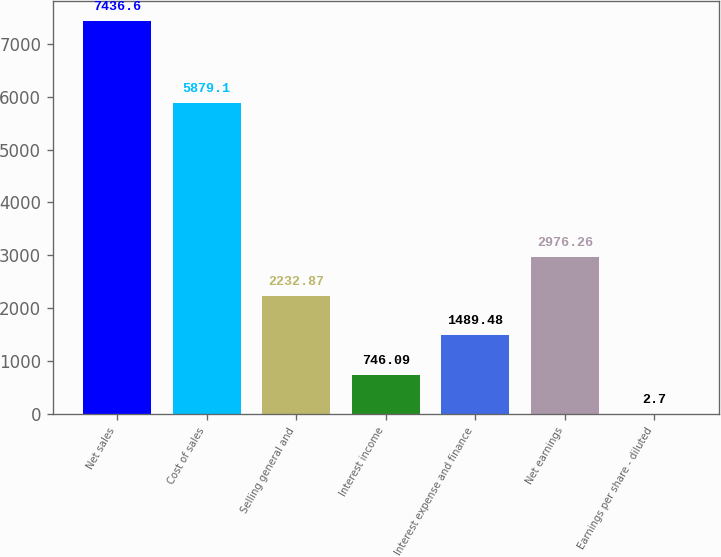Convert chart to OTSL. <chart><loc_0><loc_0><loc_500><loc_500><bar_chart><fcel>Net sales<fcel>Cost of sales<fcel>Selling general and<fcel>Interest income<fcel>Interest expense and finance<fcel>Net earnings<fcel>Earnings per share - diluted<nl><fcel>7436.6<fcel>5879.1<fcel>2232.87<fcel>746.09<fcel>1489.48<fcel>2976.26<fcel>2.7<nl></chart> 